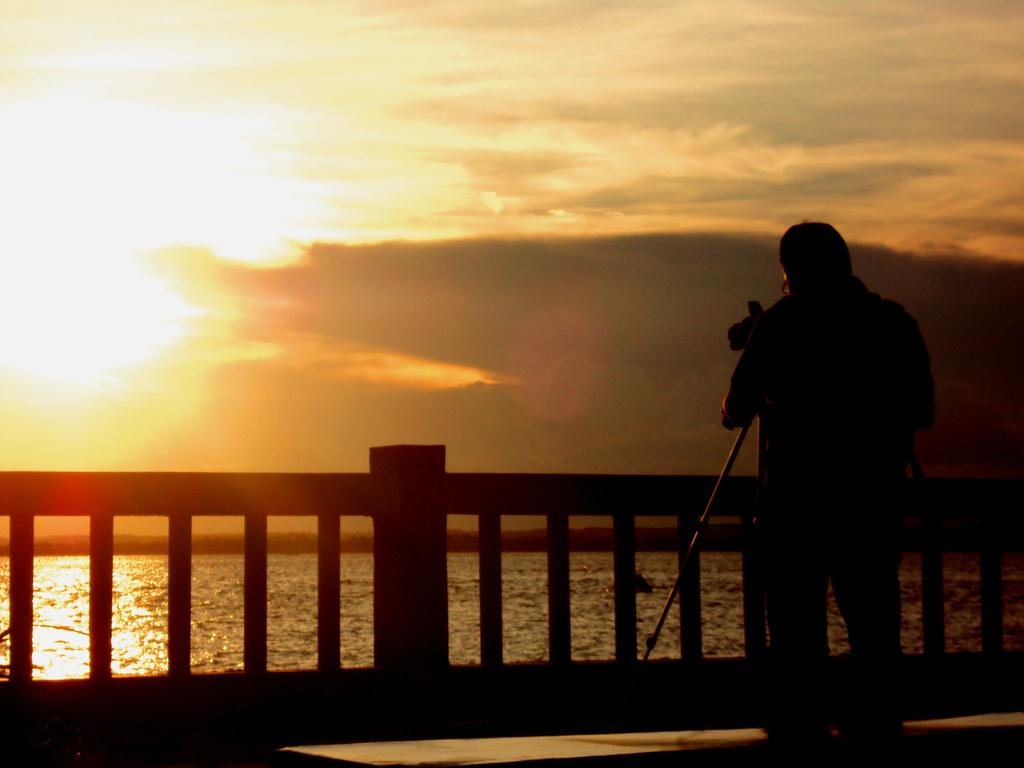What is the person in the image holding? The person is holding a tripod with a camera. What can be seen in the background of the image? There is sky, clouds, water, and a fence visible in the background of the image. What type of terrain might be suggested by the presence of water and a fence? The presence of water and a fence might suggest a landscape near a body of water, such as a river or lake. Where is the nest located in the image? There is no nest present in the image. What type of mass can be seen floating on the water in the image? There is no mass floating on the water in the image. 